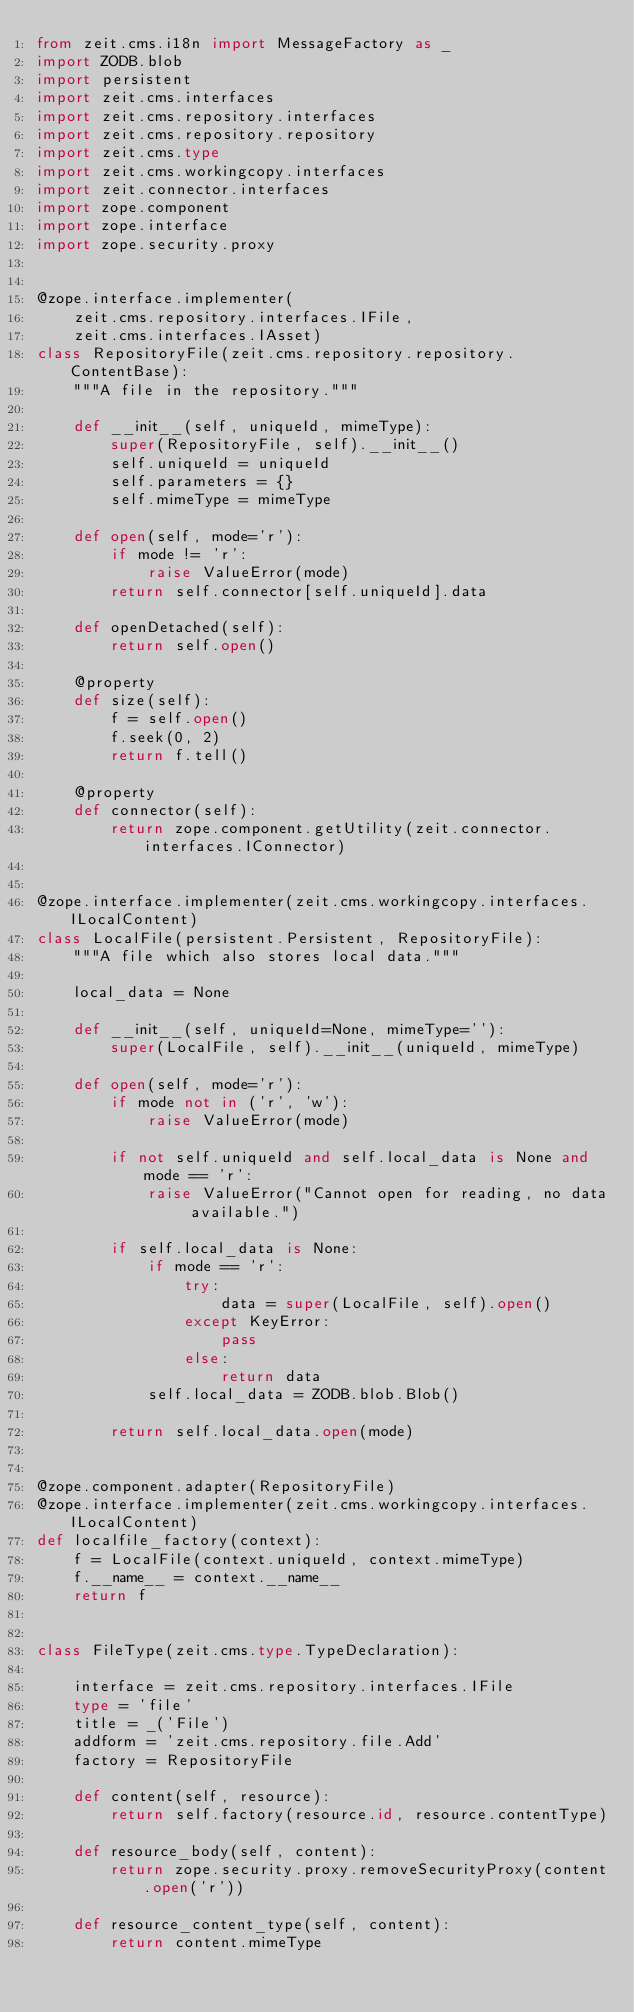<code> <loc_0><loc_0><loc_500><loc_500><_Python_>from zeit.cms.i18n import MessageFactory as _
import ZODB.blob
import persistent
import zeit.cms.interfaces
import zeit.cms.repository.interfaces
import zeit.cms.repository.repository
import zeit.cms.type
import zeit.cms.workingcopy.interfaces
import zeit.connector.interfaces
import zope.component
import zope.interface
import zope.security.proxy


@zope.interface.implementer(
    zeit.cms.repository.interfaces.IFile,
    zeit.cms.interfaces.IAsset)
class RepositoryFile(zeit.cms.repository.repository.ContentBase):
    """A file in the repository."""

    def __init__(self, uniqueId, mimeType):
        super(RepositoryFile, self).__init__()
        self.uniqueId = uniqueId
        self.parameters = {}
        self.mimeType = mimeType

    def open(self, mode='r'):
        if mode != 'r':
            raise ValueError(mode)
        return self.connector[self.uniqueId].data

    def openDetached(self):
        return self.open()

    @property
    def size(self):
        f = self.open()
        f.seek(0, 2)
        return f.tell()

    @property
    def connector(self):
        return zope.component.getUtility(zeit.connector.interfaces.IConnector)


@zope.interface.implementer(zeit.cms.workingcopy.interfaces.ILocalContent)
class LocalFile(persistent.Persistent, RepositoryFile):
    """A file which also stores local data."""

    local_data = None

    def __init__(self, uniqueId=None, mimeType=''):
        super(LocalFile, self).__init__(uniqueId, mimeType)

    def open(self, mode='r'):
        if mode not in ('r', 'w'):
            raise ValueError(mode)

        if not self.uniqueId and self.local_data is None and mode == 'r':
            raise ValueError("Cannot open for reading, no data available.")

        if self.local_data is None:
            if mode == 'r':
                try:
                    data = super(LocalFile, self).open()
                except KeyError:
                    pass
                else:
                    return data
            self.local_data = ZODB.blob.Blob()

        return self.local_data.open(mode)


@zope.component.adapter(RepositoryFile)
@zope.interface.implementer(zeit.cms.workingcopy.interfaces.ILocalContent)
def localfile_factory(context):
    f = LocalFile(context.uniqueId, context.mimeType)
    f.__name__ = context.__name__
    return f


class FileType(zeit.cms.type.TypeDeclaration):

    interface = zeit.cms.repository.interfaces.IFile
    type = 'file'
    title = _('File')
    addform = 'zeit.cms.repository.file.Add'
    factory = RepositoryFile

    def content(self, resource):
        return self.factory(resource.id, resource.contentType)

    def resource_body(self, content):
        return zope.security.proxy.removeSecurityProxy(content.open('r'))

    def resource_content_type(self, content):
        return content.mimeType
</code> 